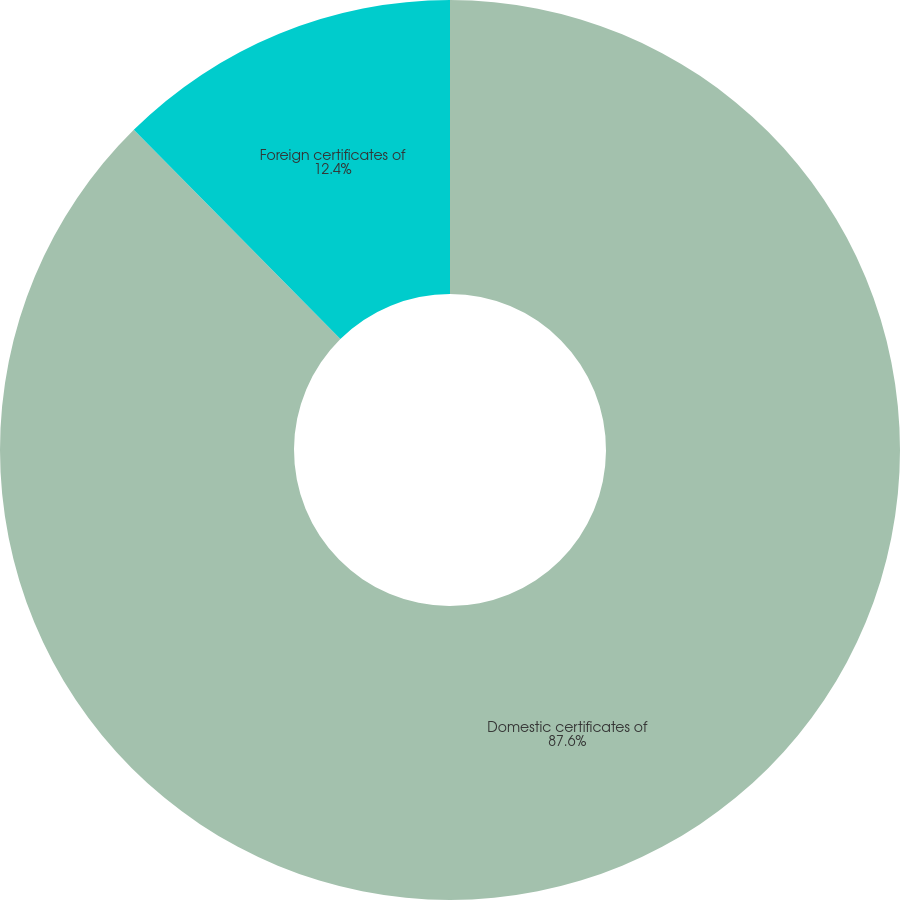Convert chart to OTSL. <chart><loc_0><loc_0><loc_500><loc_500><pie_chart><fcel>Domestic certificates of<fcel>Foreign certificates of<nl><fcel>87.6%<fcel>12.4%<nl></chart> 